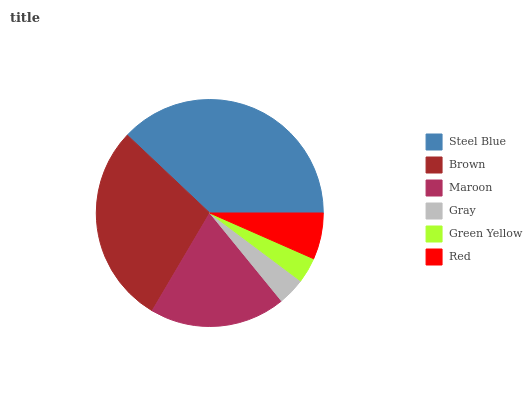Is Green Yellow the minimum?
Answer yes or no. Yes. Is Steel Blue the maximum?
Answer yes or no. Yes. Is Brown the minimum?
Answer yes or no. No. Is Brown the maximum?
Answer yes or no. No. Is Steel Blue greater than Brown?
Answer yes or no. Yes. Is Brown less than Steel Blue?
Answer yes or no. Yes. Is Brown greater than Steel Blue?
Answer yes or no. No. Is Steel Blue less than Brown?
Answer yes or no. No. Is Maroon the high median?
Answer yes or no. Yes. Is Red the low median?
Answer yes or no. Yes. Is Green Yellow the high median?
Answer yes or no. No. Is Green Yellow the low median?
Answer yes or no. No. 